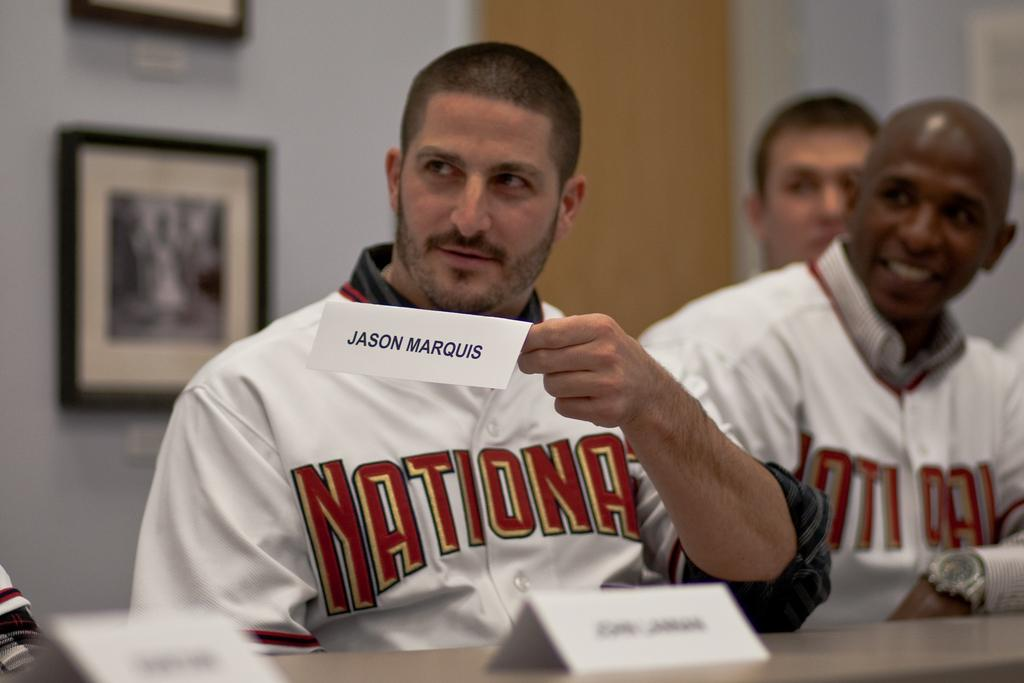<image>
Relay a brief, clear account of the picture shown. A man in a Nationals jersey is holding up a table name marker for Jason Marquis. 